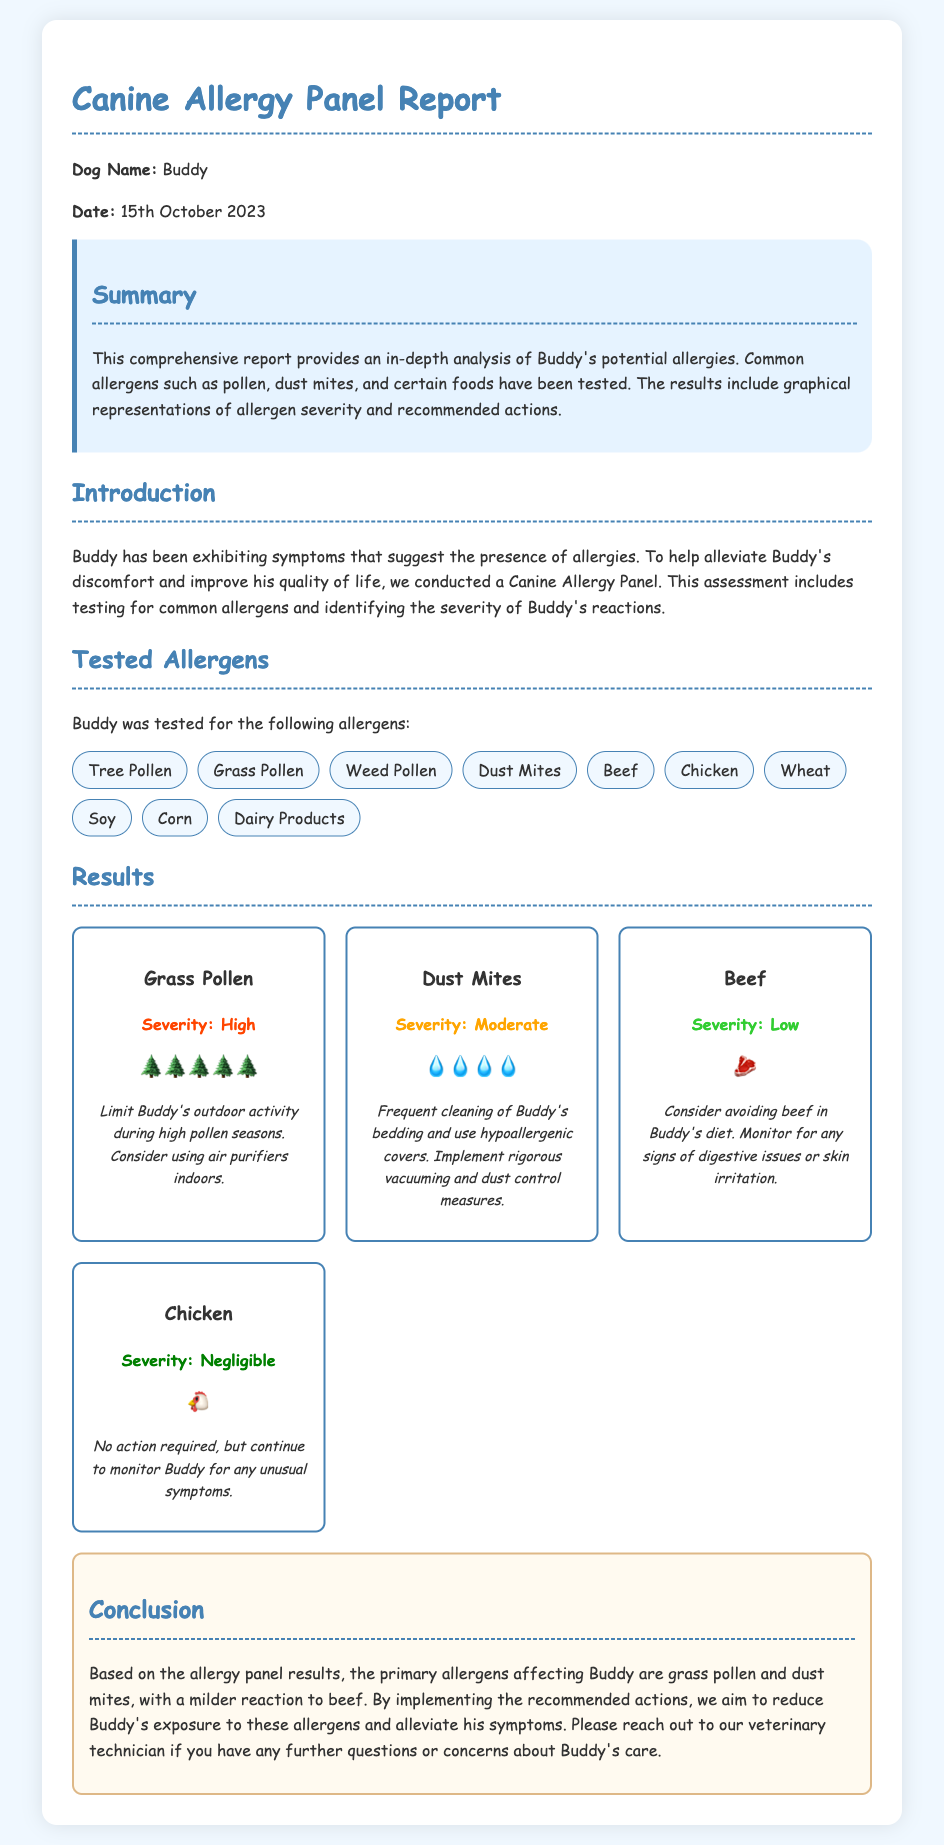What is the name of the dog tested? The report mentions that the dog's name is Buddy.
Answer: Buddy What is the date of the allergy panel report? The date specified in the document is 15th October 2023.
Answer: 15th October 2023 Which allergen has a severity level of High? Among the allergies tested, Grass Pollen is noted to have a High severity level.
Answer: Grass Pollen What is the severity level of Chicken? The report indicates that Chicken has a Negligible severity level.
Answer: Negligible What cleaning measure is recommended for Dust Mites? The document suggests frequent cleaning of Buddy's bedding and use of hypoallergenic covers.
Answer: Frequent cleaning of Buddy's bedding and use hypoallergenic covers How many allergens were tested in total? The report lists a total of ten tested allergens.
Answer: Ten What allergen is Buddy advised to avoid in his diet? The recommendation states that Buddy should avoid Beef in his diet.
Answer: Beef What graphical representation is used for communication? The document uses emoji symbols to represent the severity of allergens visually.
Answer: Emoji symbols What should be monitored in relation to Beef? The report indicates monitoring for any signs of digestive issues or skin irritation related to Beef.
Answer: Signs of digestive issues or skin irritation 